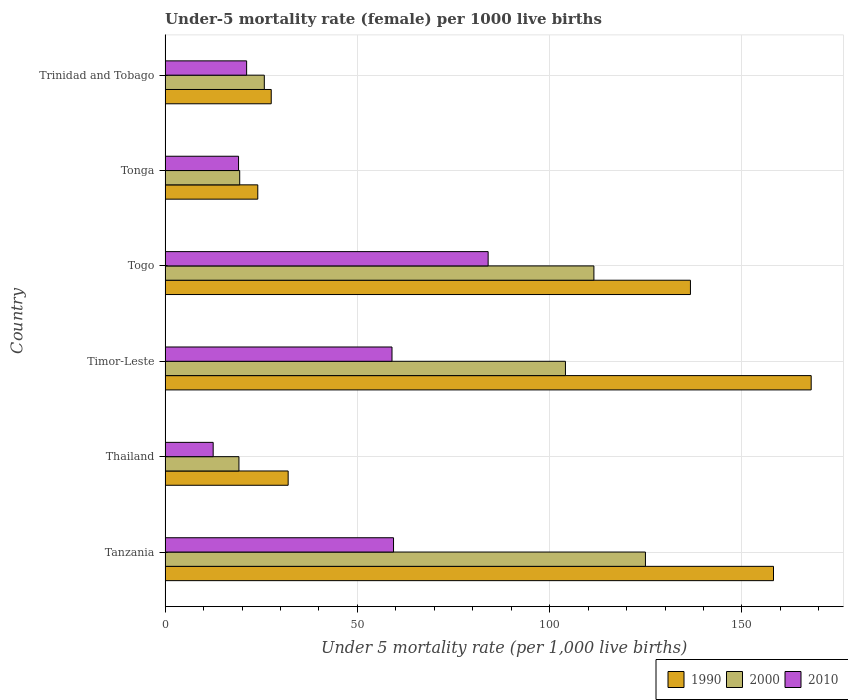Are the number of bars per tick equal to the number of legend labels?
Your answer should be compact. Yes. What is the label of the 5th group of bars from the top?
Your answer should be very brief. Thailand. In how many cases, is the number of bars for a given country not equal to the number of legend labels?
Your answer should be compact. 0. Across all countries, what is the maximum under-five mortality rate in 2010?
Ensure brevity in your answer.  84. Across all countries, what is the minimum under-five mortality rate in 2010?
Ensure brevity in your answer.  12.5. In which country was the under-five mortality rate in 2000 maximum?
Your answer should be compact. Tanzania. In which country was the under-five mortality rate in 2010 minimum?
Keep it short and to the point. Thailand. What is the total under-five mortality rate in 2010 in the graph?
Ensure brevity in your answer.  255.2. What is the difference between the under-five mortality rate in 2010 in Togo and that in Trinidad and Tobago?
Make the answer very short. 62.8. What is the difference between the under-five mortality rate in 1990 in Tonga and the under-five mortality rate in 2010 in Thailand?
Provide a short and direct response. 11.6. What is the average under-five mortality rate in 2000 per country?
Make the answer very short. 67.48. What is the difference between the under-five mortality rate in 1990 and under-five mortality rate in 2010 in Togo?
Give a very brief answer. 52.6. In how many countries, is the under-five mortality rate in 1990 greater than 80 ?
Make the answer very short. 3. What is the ratio of the under-five mortality rate in 2010 in Togo to that in Trinidad and Tobago?
Keep it short and to the point. 3.96. Is the difference between the under-five mortality rate in 1990 in Thailand and Timor-Leste greater than the difference between the under-five mortality rate in 2010 in Thailand and Timor-Leste?
Offer a terse response. No. What is the difference between the highest and the second highest under-five mortality rate in 2000?
Offer a very short reply. 13.4. What is the difference between the highest and the lowest under-five mortality rate in 1990?
Your answer should be compact. 143.9. In how many countries, is the under-five mortality rate in 1990 greater than the average under-five mortality rate in 1990 taken over all countries?
Keep it short and to the point. 3. What does the 2nd bar from the bottom in Tanzania represents?
Make the answer very short. 2000. What is the difference between two consecutive major ticks on the X-axis?
Offer a terse response. 50. Are the values on the major ticks of X-axis written in scientific E-notation?
Ensure brevity in your answer.  No. How are the legend labels stacked?
Keep it short and to the point. Horizontal. What is the title of the graph?
Ensure brevity in your answer.  Under-5 mortality rate (female) per 1000 live births. What is the label or title of the X-axis?
Keep it short and to the point. Under 5 mortality rate (per 1,0 live births). What is the label or title of the Y-axis?
Your response must be concise. Country. What is the Under 5 mortality rate (per 1,000 live births) of 1990 in Tanzania?
Offer a very short reply. 158.2. What is the Under 5 mortality rate (per 1,000 live births) in 2000 in Tanzania?
Ensure brevity in your answer.  124.9. What is the Under 5 mortality rate (per 1,000 live births) in 2010 in Tanzania?
Keep it short and to the point. 59.4. What is the Under 5 mortality rate (per 1,000 live births) in 1990 in Timor-Leste?
Offer a terse response. 168. What is the Under 5 mortality rate (per 1,000 live births) of 2000 in Timor-Leste?
Ensure brevity in your answer.  104.1. What is the Under 5 mortality rate (per 1,000 live births) of 2010 in Timor-Leste?
Offer a very short reply. 59. What is the Under 5 mortality rate (per 1,000 live births) in 1990 in Togo?
Give a very brief answer. 136.6. What is the Under 5 mortality rate (per 1,000 live births) in 2000 in Togo?
Provide a short and direct response. 111.5. What is the Under 5 mortality rate (per 1,000 live births) of 2010 in Togo?
Give a very brief answer. 84. What is the Under 5 mortality rate (per 1,000 live births) of 1990 in Tonga?
Your answer should be compact. 24.1. What is the Under 5 mortality rate (per 1,000 live births) of 2010 in Tonga?
Give a very brief answer. 19.1. What is the Under 5 mortality rate (per 1,000 live births) in 1990 in Trinidad and Tobago?
Your answer should be very brief. 27.6. What is the Under 5 mortality rate (per 1,000 live births) of 2000 in Trinidad and Tobago?
Provide a succinct answer. 25.8. What is the Under 5 mortality rate (per 1,000 live births) in 2010 in Trinidad and Tobago?
Your answer should be very brief. 21.2. Across all countries, what is the maximum Under 5 mortality rate (per 1,000 live births) in 1990?
Make the answer very short. 168. Across all countries, what is the maximum Under 5 mortality rate (per 1,000 live births) in 2000?
Offer a terse response. 124.9. Across all countries, what is the minimum Under 5 mortality rate (per 1,000 live births) of 1990?
Make the answer very short. 24.1. Across all countries, what is the minimum Under 5 mortality rate (per 1,000 live births) in 2000?
Provide a short and direct response. 19.2. What is the total Under 5 mortality rate (per 1,000 live births) of 1990 in the graph?
Your response must be concise. 546.5. What is the total Under 5 mortality rate (per 1,000 live births) of 2000 in the graph?
Keep it short and to the point. 404.9. What is the total Under 5 mortality rate (per 1,000 live births) in 2010 in the graph?
Offer a very short reply. 255.2. What is the difference between the Under 5 mortality rate (per 1,000 live births) in 1990 in Tanzania and that in Thailand?
Give a very brief answer. 126.2. What is the difference between the Under 5 mortality rate (per 1,000 live births) of 2000 in Tanzania and that in Thailand?
Offer a terse response. 105.7. What is the difference between the Under 5 mortality rate (per 1,000 live births) in 2010 in Tanzania and that in Thailand?
Offer a terse response. 46.9. What is the difference between the Under 5 mortality rate (per 1,000 live births) in 2000 in Tanzania and that in Timor-Leste?
Offer a very short reply. 20.8. What is the difference between the Under 5 mortality rate (per 1,000 live births) of 2010 in Tanzania and that in Timor-Leste?
Offer a very short reply. 0.4. What is the difference between the Under 5 mortality rate (per 1,000 live births) in 1990 in Tanzania and that in Togo?
Give a very brief answer. 21.6. What is the difference between the Under 5 mortality rate (per 1,000 live births) of 2000 in Tanzania and that in Togo?
Make the answer very short. 13.4. What is the difference between the Under 5 mortality rate (per 1,000 live births) in 2010 in Tanzania and that in Togo?
Your answer should be compact. -24.6. What is the difference between the Under 5 mortality rate (per 1,000 live births) in 1990 in Tanzania and that in Tonga?
Your answer should be compact. 134.1. What is the difference between the Under 5 mortality rate (per 1,000 live births) of 2000 in Tanzania and that in Tonga?
Give a very brief answer. 105.5. What is the difference between the Under 5 mortality rate (per 1,000 live births) in 2010 in Tanzania and that in Tonga?
Your response must be concise. 40.3. What is the difference between the Under 5 mortality rate (per 1,000 live births) in 1990 in Tanzania and that in Trinidad and Tobago?
Provide a short and direct response. 130.6. What is the difference between the Under 5 mortality rate (per 1,000 live births) of 2000 in Tanzania and that in Trinidad and Tobago?
Provide a short and direct response. 99.1. What is the difference between the Under 5 mortality rate (per 1,000 live births) of 2010 in Tanzania and that in Trinidad and Tobago?
Provide a succinct answer. 38.2. What is the difference between the Under 5 mortality rate (per 1,000 live births) in 1990 in Thailand and that in Timor-Leste?
Make the answer very short. -136. What is the difference between the Under 5 mortality rate (per 1,000 live births) in 2000 in Thailand and that in Timor-Leste?
Keep it short and to the point. -84.9. What is the difference between the Under 5 mortality rate (per 1,000 live births) of 2010 in Thailand and that in Timor-Leste?
Give a very brief answer. -46.5. What is the difference between the Under 5 mortality rate (per 1,000 live births) of 1990 in Thailand and that in Togo?
Your answer should be compact. -104.6. What is the difference between the Under 5 mortality rate (per 1,000 live births) of 2000 in Thailand and that in Togo?
Your answer should be very brief. -92.3. What is the difference between the Under 5 mortality rate (per 1,000 live births) in 2010 in Thailand and that in Togo?
Provide a short and direct response. -71.5. What is the difference between the Under 5 mortality rate (per 1,000 live births) of 2000 in Thailand and that in Tonga?
Give a very brief answer. -0.2. What is the difference between the Under 5 mortality rate (per 1,000 live births) of 2010 in Thailand and that in Tonga?
Your response must be concise. -6.6. What is the difference between the Under 5 mortality rate (per 1,000 live births) in 1990 in Timor-Leste and that in Togo?
Provide a short and direct response. 31.4. What is the difference between the Under 5 mortality rate (per 1,000 live births) in 2010 in Timor-Leste and that in Togo?
Your answer should be very brief. -25. What is the difference between the Under 5 mortality rate (per 1,000 live births) in 1990 in Timor-Leste and that in Tonga?
Give a very brief answer. 143.9. What is the difference between the Under 5 mortality rate (per 1,000 live births) in 2000 in Timor-Leste and that in Tonga?
Give a very brief answer. 84.7. What is the difference between the Under 5 mortality rate (per 1,000 live births) in 2010 in Timor-Leste and that in Tonga?
Keep it short and to the point. 39.9. What is the difference between the Under 5 mortality rate (per 1,000 live births) of 1990 in Timor-Leste and that in Trinidad and Tobago?
Make the answer very short. 140.4. What is the difference between the Under 5 mortality rate (per 1,000 live births) of 2000 in Timor-Leste and that in Trinidad and Tobago?
Your response must be concise. 78.3. What is the difference between the Under 5 mortality rate (per 1,000 live births) of 2010 in Timor-Leste and that in Trinidad and Tobago?
Keep it short and to the point. 37.8. What is the difference between the Under 5 mortality rate (per 1,000 live births) in 1990 in Togo and that in Tonga?
Make the answer very short. 112.5. What is the difference between the Under 5 mortality rate (per 1,000 live births) of 2000 in Togo and that in Tonga?
Keep it short and to the point. 92.1. What is the difference between the Under 5 mortality rate (per 1,000 live births) of 2010 in Togo and that in Tonga?
Your answer should be compact. 64.9. What is the difference between the Under 5 mortality rate (per 1,000 live births) in 1990 in Togo and that in Trinidad and Tobago?
Offer a very short reply. 109. What is the difference between the Under 5 mortality rate (per 1,000 live births) in 2000 in Togo and that in Trinidad and Tobago?
Your response must be concise. 85.7. What is the difference between the Under 5 mortality rate (per 1,000 live births) of 2010 in Togo and that in Trinidad and Tobago?
Offer a terse response. 62.8. What is the difference between the Under 5 mortality rate (per 1,000 live births) of 2000 in Tonga and that in Trinidad and Tobago?
Your answer should be compact. -6.4. What is the difference between the Under 5 mortality rate (per 1,000 live births) in 2010 in Tonga and that in Trinidad and Tobago?
Ensure brevity in your answer.  -2.1. What is the difference between the Under 5 mortality rate (per 1,000 live births) of 1990 in Tanzania and the Under 5 mortality rate (per 1,000 live births) of 2000 in Thailand?
Your answer should be very brief. 139. What is the difference between the Under 5 mortality rate (per 1,000 live births) in 1990 in Tanzania and the Under 5 mortality rate (per 1,000 live births) in 2010 in Thailand?
Your answer should be compact. 145.7. What is the difference between the Under 5 mortality rate (per 1,000 live births) of 2000 in Tanzania and the Under 5 mortality rate (per 1,000 live births) of 2010 in Thailand?
Your answer should be compact. 112.4. What is the difference between the Under 5 mortality rate (per 1,000 live births) in 1990 in Tanzania and the Under 5 mortality rate (per 1,000 live births) in 2000 in Timor-Leste?
Ensure brevity in your answer.  54.1. What is the difference between the Under 5 mortality rate (per 1,000 live births) in 1990 in Tanzania and the Under 5 mortality rate (per 1,000 live births) in 2010 in Timor-Leste?
Provide a succinct answer. 99.2. What is the difference between the Under 5 mortality rate (per 1,000 live births) of 2000 in Tanzania and the Under 5 mortality rate (per 1,000 live births) of 2010 in Timor-Leste?
Offer a very short reply. 65.9. What is the difference between the Under 5 mortality rate (per 1,000 live births) in 1990 in Tanzania and the Under 5 mortality rate (per 1,000 live births) in 2000 in Togo?
Provide a short and direct response. 46.7. What is the difference between the Under 5 mortality rate (per 1,000 live births) in 1990 in Tanzania and the Under 5 mortality rate (per 1,000 live births) in 2010 in Togo?
Provide a short and direct response. 74.2. What is the difference between the Under 5 mortality rate (per 1,000 live births) of 2000 in Tanzania and the Under 5 mortality rate (per 1,000 live births) of 2010 in Togo?
Make the answer very short. 40.9. What is the difference between the Under 5 mortality rate (per 1,000 live births) in 1990 in Tanzania and the Under 5 mortality rate (per 1,000 live births) in 2000 in Tonga?
Offer a terse response. 138.8. What is the difference between the Under 5 mortality rate (per 1,000 live births) in 1990 in Tanzania and the Under 5 mortality rate (per 1,000 live births) in 2010 in Tonga?
Give a very brief answer. 139.1. What is the difference between the Under 5 mortality rate (per 1,000 live births) of 2000 in Tanzania and the Under 5 mortality rate (per 1,000 live births) of 2010 in Tonga?
Your response must be concise. 105.8. What is the difference between the Under 5 mortality rate (per 1,000 live births) of 1990 in Tanzania and the Under 5 mortality rate (per 1,000 live births) of 2000 in Trinidad and Tobago?
Your response must be concise. 132.4. What is the difference between the Under 5 mortality rate (per 1,000 live births) in 1990 in Tanzania and the Under 5 mortality rate (per 1,000 live births) in 2010 in Trinidad and Tobago?
Your answer should be compact. 137. What is the difference between the Under 5 mortality rate (per 1,000 live births) in 2000 in Tanzania and the Under 5 mortality rate (per 1,000 live births) in 2010 in Trinidad and Tobago?
Your response must be concise. 103.7. What is the difference between the Under 5 mortality rate (per 1,000 live births) of 1990 in Thailand and the Under 5 mortality rate (per 1,000 live births) of 2000 in Timor-Leste?
Ensure brevity in your answer.  -72.1. What is the difference between the Under 5 mortality rate (per 1,000 live births) in 2000 in Thailand and the Under 5 mortality rate (per 1,000 live births) in 2010 in Timor-Leste?
Ensure brevity in your answer.  -39.8. What is the difference between the Under 5 mortality rate (per 1,000 live births) of 1990 in Thailand and the Under 5 mortality rate (per 1,000 live births) of 2000 in Togo?
Give a very brief answer. -79.5. What is the difference between the Under 5 mortality rate (per 1,000 live births) of 1990 in Thailand and the Under 5 mortality rate (per 1,000 live births) of 2010 in Togo?
Make the answer very short. -52. What is the difference between the Under 5 mortality rate (per 1,000 live births) of 2000 in Thailand and the Under 5 mortality rate (per 1,000 live births) of 2010 in Togo?
Your answer should be compact. -64.8. What is the difference between the Under 5 mortality rate (per 1,000 live births) in 1990 in Thailand and the Under 5 mortality rate (per 1,000 live births) in 2010 in Tonga?
Keep it short and to the point. 12.9. What is the difference between the Under 5 mortality rate (per 1,000 live births) in 2000 in Thailand and the Under 5 mortality rate (per 1,000 live births) in 2010 in Tonga?
Make the answer very short. 0.1. What is the difference between the Under 5 mortality rate (per 1,000 live births) of 1990 in Thailand and the Under 5 mortality rate (per 1,000 live births) of 2000 in Trinidad and Tobago?
Ensure brevity in your answer.  6.2. What is the difference between the Under 5 mortality rate (per 1,000 live births) in 1990 in Thailand and the Under 5 mortality rate (per 1,000 live births) in 2010 in Trinidad and Tobago?
Keep it short and to the point. 10.8. What is the difference between the Under 5 mortality rate (per 1,000 live births) of 1990 in Timor-Leste and the Under 5 mortality rate (per 1,000 live births) of 2000 in Togo?
Give a very brief answer. 56.5. What is the difference between the Under 5 mortality rate (per 1,000 live births) of 2000 in Timor-Leste and the Under 5 mortality rate (per 1,000 live births) of 2010 in Togo?
Offer a terse response. 20.1. What is the difference between the Under 5 mortality rate (per 1,000 live births) in 1990 in Timor-Leste and the Under 5 mortality rate (per 1,000 live births) in 2000 in Tonga?
Provide a short and direct response. 148.6. What is the difference between the Under 5 mortality rate (per 1,000 live births) of 1990 in Timor-Leste and the Under 5 mortality rate (per 1,000 live births) of 2010 in Tonga?
Provide a short and direct response. 148.9. What is the difference between the Under 5 mortality rate (per 1,000 live births) in 2000 in Timor-Leste and the Under 5 mortality rate (per 1,000 live births) in 2010 in Tonga?
Provide a succinct answer. 85. What is the difference between the Under 5 mortality rate (per 1,000 live births) of 1990 in Timor-Leste and the Under 5 mortality rate (per 1,000 live births) of 2000 in Trinidad and Tobago?
Offer a terse response. 142.2. What is the difference between the Under 5 mortality rate (per 1,000 live births) in 1990 in Timor-Leste and the Under 5 mortality rate (per 1,000 live births) in 2010 in Trinidad and Tobago?
Your answer should be compact. 146.8. What is the difference between the Under 5 mortality rate (per 1,000 live births) of 2000 in Timor-Leste and the Under 5 mortality rate (per 1,000 live births) of 2010 in Trinidad and Tobago?
Keep it short and to the point. 82.9. What is the difference between the Under 5 mortality rate (per 1,000 live births) in 1990 in Togo and the Under 5 mortality rate (per 1,000 live births) in 2000 in Tonga?
Ensure brevity in your answer.  117.2. What is the difference between the Under 5 mortality rate (per 1,000 live births) in 1990 in Togo and the Under 5 mortality rate (per 1,000 live births) in 2010 in Tonga?
Your answer should be compact. 117.5. What is the difference between the Under 5 mortality rate (per 1,000 live births) in 2000 in Togo and the Under 5 mortality rate (per 1,000 live births) in 2010 in Tonga?
Offer a very short reply. 92.4. What is the difference between the Under 5 mortality rate (per 1,000 live births) of 1990 in Togo and the Under 5 mortality rate (per 1,000 live births) of 2000 in Trinidad and Tobago?
Give a very brief answer. 110.8. What is the difference between the Under 5 mortality rate (per 1,000 live births) in 1990 in Togo and the Under 5 mortality rate (per 1,000 live births) in 2010 in Trinidad and Tobago?
Make the answer very short. 115.4. What is the difference between the Under 5 mortality rate (per 1,000 live births) in 2000 in Togo and the Under 5 mortality rate (per 1,000 live births) in 2010 in Trinidad and Tobago?
Your answer should be very brief. 90.3. What is the difference between the Under 5 mortality rate (per 1,000 live births) of 1990 in Tonga and the Under 5 mortality rate (per 1,000 live births) of 2010 in Trinidad and Tobago?
Your answer should be compact. 2.9. What is the average Under 5 mortality rate (per 1,000 live births) of 1990 per country?
Provide a short and direct response. 91.08. What is the average Under 5 mortality rate (per 1,000 live births) in 2000 per country?
Your answer should be very brief. 67.48. What is the average Under 5 mortality rate (per 1,000 live births) in 2010 per country?
Offer a very short reply. 42.53. What is the difference between the Under 5 mortality rate (per 1,000 live births) of 1990 and Under 5 mortality rate (per 1,000 live births) of 2000 in Tanzania?
Ensure brevity in your answer.  33.3. What is the difference between the Under 5 mortality rate (per 1,000 live births) in 1990 and Under 5 mortality rate (per 1,000 live births) in 2010 in Tanzania?
Give a very brief answer. 98.8. What is the difference between the Under 5 mortality rate (per 1,000 live births) in 2000 and Under 5 mortality rate (per 1,000 live births) in 2010 in Tanzania?
Offer a terse response. 65.5. What is the difference between the Under 5 mortality rate (per 1,000 live births) of 1990 and Under 5 mortality rate (per 1,000 live births) of 2000 in Thailand?
Ensure brevity in your answer.  12.8. What is the difference between the Under 5 mortality rate (per 1,000 live births) in 2000 and Under 5 mortality rate (per 1,000 live births) in 2010 in Thailand?
Offer a very short reply. 6.7. What is the difference between the Under 5 mortality rate (per 1,000 live births) in 1990 and Under 5 mortality rate (per 1,000 live births) in 2000 in Timor-Leste?
Offer a terse response. 63.9. What is the difference between the Under 5 mortality rate (per 1,000 live births) of 1990 and Under 5 mortality rate (per 1,000 live births) of 2010 in Timor-Leste?
Provide a short and direct response. 109. What is the difference between the Under 5 mortality rate (per 1,000 live births) of 2000 and Under 5 mortality rate (per 1,000 live births) of 2010 in Timor-Leste?
Your answer should be very brief. 45.1. What is the difference between the Under 5 mortality rate (per 1,000 live births) of 1990 and Under 5 mortality rate (per 1,000 live births) of 2000 in Togo?
Make the answer very short. 25.1. What is the difference between the Under 5 mortality rate (per 1,000 live births) in 1990 and Under 5 mortality rate (per 1,000 live births) in 2010 in Togo?
Give a very brief answer. 52.6. What is the difference between the Under 5 mortality rate (per 1,000 live births) of 2000 and Under 5 mortality rate (per 1,000 live births) of 2010 in Tonga?
Provide a succinct answer. 0.3. What is the difference between the Under 5 mortality rate (per 1,000 live births) in 2000 and Under 5 mortality rate (per 1,000 live births) in 2010 in Trinidad and Tobago?
Offer a terse response. 4.6. What is the ratio of the Under 5 mortality rate (per 1,000 live births) in 1990 in Tanzania to that in Thailand?
Ensure brevity in your answer.  4.94. What is the ratio of the Under 5 mortality rate (per 1,000 live births) in 2000 in Tanzania to that in Thailand?
Ensure brevity in your answer.  6.51. What is the ratio of the Under 5 mortality rate (per 1,000 live births) in 2010 in Tanzania to that in Thailand?
Give a very brief answer. 4.75. What is the ratio of the Under 5 mortality rate (per 1,000 live births) of 1990 in Tanzania to that in Timor-Leste?
Provide a short and direct response. 0.94. What is the ratio of the Under 5 mortality rate (per 1,000 live births) in 2000 in Tanzania to that in Timor-Leste?
Keep it short and to the point. 1.2. What is the ratio of the Under 5 mortality rate (per 1,000 live births) in 2010 in Tanzania to that in Timor-Leste?
Offer a very short reply. 1.01. What is the ratio of the Under 5 mortality rate (per 1,000 live births) of 1990 in Tanzania to that in Togo?
Make the answer very short. 1.16. What is the ratio of the Under 5 mortality rate (per 1,000 live births) of 2000 in Tanzania to that in Togo?
Your answer should be compact. 1.12. What is the ratio of the Under 5 mortality rate (per 1,000 live births) in 2010 in Tanzania to that in Togo?
Your answer should be very brief. 0.71. What is the ratio of the Under 5 mortality rate (per 1,000 live births) in 1990 in Tanzania to that in Tonga?
Make the answer very short. 6.56. What is the ratio of the Under 5 mortality rate (per 1,000 live births) in 2000 in Tanzania to that in Tonga?
Ensure brevity in your answer.  6.44. What is the ratio of the Under 5 mortality rate (per 1,000 live births) in 2010 in Tanzania to that in Tonga?
Keep it short and to the point. 3.11. What is the ratio of the Under 5 mortality rate (per 1,000 live births) in 1990 in Tanzania to that in Trinidad and Tobago?
Provide a short and direct response. 5.73. What is the ratio of the Under 5 mortality rate (per 1,000 live births) of 2000 in Tanzania to that in Trinidad and Tobago?
Your response must be concise. 4.84. What is the ratio of the Under 5 mortality rate (per 1,000 live births) of 2010 in Tanzania to that in Trinidad and Tobago?
Offer a terse response. 2.8. What is the ratio of the Under 5 mortality rate (per 1,000 live births) of 1990 in Thailand to that in Timor-Leste?
Provide a short and direct response. 0.19. What is the ratio of the Under 5 mortality rate (per 1,000 live births) of 2000 in Thailand to that in Timor-Leste?
Provide a short and direct response. 0.18. What is the ratio of the Under 5 mortality rate (per 1,000 live births) of 2010 in Thailand to that in Timor-Leste?
Your answer should be compact. 0.21. What is the ratio of the Under 5 mortality rate (per 1,000 live births) in 1990 in Thailand to that in Togo?
Offer a terse response. 0.23. What is the ratio of the Under 5 mortality rate (per 1,000 live births) of 2000 in Thailand to that in Togo?
Keep it short and to the point. 0.17. What is the ratio of the Under 5 mortality rate (per 1,000 live births) in 2010 in Thailand to that in Togo?
Offer a terse response. 0.15. What is the ratio of the Under 5 mortality rate (per 1,000 live births) of 1990 in Thailand to that in Tonga?
Make the answer very short. 1.33. What is the ratio of the Under 5 mortality rate (per 1,000 live births) of 2000 in Thailand to that in Tonga?
Ensure brevity in your answer.  0.99. What is the ratio of the Under 5 mortality rate (per 1,000 live births) in 2010 in Thailand to that in Tonga?
Provide a succinct answer. 0.65. What is the ratio of the Under 5 mortality rate (per 1,000 live births) in 1990 in Thailand to that in Trinidad and Tobago?
Your answer should be very brief. 1.16. What is the ratio of the Under 5 mortality rate (per 1,000 live births) of 2000 in Thailand to that in Trinidad and Tobago?
Provide a short and direct response. 0.74. What is the ratio of the Under 5 mortality rate (per 1,000 live births) of 2010 in Thailand to that in Trinidad and Tobago?
Make the answer very short. 0.59. What is the ratio of the Under 5 mortality rate (per 1,000 live births) of 1990 in Timor-Leste to that in Togo?
Your response must be concise. 1.23. What is the ratio of the Under 5 mortality rate (per 1,000 live births) in 2000 in Timor-Leste to that in Togo?
Keep it short and to the point. 0.93. What is the ratio of the Under 5 mortality rate (per 1,000 live births) of 2010 in Timor-Leste to that in Togo?
Your response must be concise. 0.7. What is the ratio of the Under 5 mortality rate (per 1,000 live births) in 1990 in Timor-Leste to that in Tonga?
Your answer should be very brief. 6.97. What is the ratio of the Under 5 mortality rate (per 1,000 live births) in 2000 in Timor-Leste to that in Tonga?
Your answer should be compact. 5.37. What is the ratio of the Under 5 mortality rate (per 1,000 live births) of 2010 in Timor-Leste to that in Tonga?
Provide a succinct answer. 3.09. What is the ratio of the Under 5 mortality rate (per 1,000 live births) in 1990 in Timor-Leste to that in Trinidad and Tobago?
Offer a terse response. 6.09. What is the ratio of the Under 5 mortality rate (per 1,000 live births) of 2000 in Timor-Leste to that in Trinidad and Tobago?
Your response must be concise. 4.03. What is the ratio of the Under 5 mortality rate (per 1,000 live births) of 2010 in Timor-Leste to that in Trinidad and Tobago?
Give a very brief answer. 2.78. What is the ratio of the Under 5 mortality rate (per 1,000 live births) of 1990 in Togo to that in Tonga?
Your response must be concise. 5.67. What is the ratio of the Under 5 mortality rate (per 1,000 live births) in 2000 in Togo to that in Tonga?
Offer a terse response. 5.75. What is the ratio of the Under 5 mortality rate (per 1,000 live births) in 2010 in Togo to that in Tonga?
Make the answer very short. 4.4. What is the ratio of the Under 5 mortality rate (per 1,000 live births) of 1990 in Togo to that in Trinidad and Tobago?
Your response must be concise. 4.95. What is the ratio of the Under 5 mortality rate (per 1,000 live births) of 2000 in Togo to that in Trinidad and Tobago?
Make the answer very short. 4.32. What is the ratio of the Under 5 mortality rate (per 1,000 live births) of 2010 in Togo to that in Trinidad and Tobago?
Your answer should be very brief. 3.96. What is the ratio of the Under 5 mortality rate (per 1,000 live births) in 1990 in Tonga to that in Trinidad and Tobago?
Provide a short and direct response. 0.87. What is the ratio of the Under 5 mortality rate (per 1,000 live births) in 2000 in Tonga to that in Trinidad and Tobago?
Make the answer very short. 0.75. What is the ratio of the Under 5 mortality rate (per 1,000 live births) of 2010 in Tonga to that in Trinidad and Tobago?
Your answer should be very brief. 0.9. What is the difference between the highest and the second highest Under 5 mortality rate (per 1,000 live births) in 1990?
Your answer should be compact. 9.8. What is the difference between the highest and the second highest Under 5 mortality rate (per 1,000 live births) in 2000?
Your answer should be very brief. 13.4. What is the difference between the highest and the second highest Under 5 mortality rate (per 1,000 live births) of 2010?
Provide a succinct answer. 24.6. What is the difference between the highest and the lowest Under 5 mortality rate (per 1,000 live births) of 1990?
Give a very brief answer. 143.9. What is the difference between the highest and the lowest Under 5 mortality rate (per 1,000 live births) in 2000?
Ensure brevity in your answer.  105.7. What is the difference between the highest and the lowest Under 5 mortality rate (per 1,000 live births) of 2010?
Offer a very short reply. 71.5. 